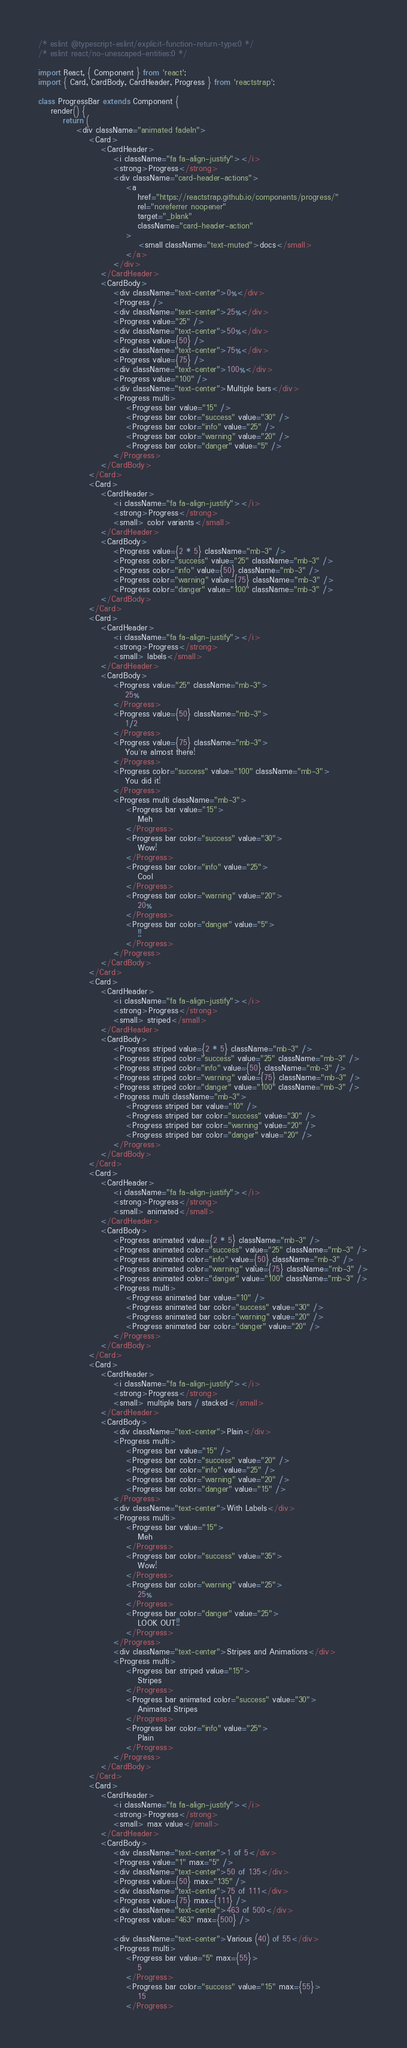Convert code to text. <code><loc_0><loc_0><loc_500><loc_500><_JavaScript_>/* eslint @typescript-eslint/explicit-function-return-type:0 */
/* eslint react/no-unescaped-entities:0 */

import React, { Component } from 'react';
import { Card, CardBody, CardHeader, Progress } from 'reactstrap';

class ProgressBar extends Component {
    render() {
        return (
            <div className="animated fadeIn">
                <Card>
                    <CardHeader>
                        <i className="fa fa-align-justify"></i>
                        <strong>Progress</strong>
                        <div className="card-header-actions">
                            <a
                                href="https://reactstrap.github.io/components/progress/"
                                rel="noreferrer noopener"
                                target="_blank"
                                className="card-header-action"
                            >
                                <small className="text-muted">docs</small>
                            </a>
                        </div>
                    </CardHeader>
                    <CardBody>
                        <div className="text-center">0%</div>
                        <Progress />
                        <div className="text-center">25%</div>
                        <Progress value="25" />
                        <div className="text-center">50%</div>
                        <Progress value={50} />
                        <div className="text-center">75%</div>
                        <Progress value={75} />
                        <div className="text-center">100%</div>
                        <Progress value="100" />
                        <div className="text-center">Multiple bars</div>
                        <Progress multi>
                            <Progress bar value="15" />
                            <Progress bar color="success" value="30" />
                            <Progress bar color="info" value="25" />
                            <Progress bar color="warning" value="20" />
                            <Progress bar color="danger" value="5" />
                        </Progress>
                    </CardBody>
                </Card>
                <Card>
                    <CardHeader>
                        <i className="fa fa-align-justify"></i>
                        <strong>Progress</strong>
                        <small> color variants</small>
                    </CardHeader>
                    <CardBody>
                        <Progress value={2 * 5} className="mb-3" />
                        <Progress color="success" value="25" className="mb-3" />
                        <Progress color="info" value={50} className="mb-3" />
                        <Progress color="warning" value={75} className="mb-3" />
                        <Progress color="danger" value="100" className="mb-3" />
                    </CardBody>
                </Card>
                <Card>
                    <CardHeader>
                        <i className="fa fa-align-justify"></i>
                        <strong>Progress</strong>
                        <small> labels</small>
                    </CardHeader>
                    <CardBody>
                        <Progress value="25" className="mb-3">
                            25%
                        </Progress>
                        <Progress value={50} className="mb-3">
                            1/2
                        </Progress>
                        <Progress value={75} className="mb-3">
                            You're almost there!
                        </Progress>
                        <Progress color="success" value="100" className="mb-3">
                            You did it!
                        </Progress>
                        <Progress multi className="mb-3">
                            <Progress bar value="15">
                                Meh
                            </Progress>
                            <Progress bar color="success" value="30">
                                Wow!
                            </Progress>
                            <Progress bar color="info" value="25">
                                Cool
                            </Progress>
                            <Progress bar color="warning" value="20">
                                20%
                            </Progress>
                            <Progress bar color="danger" value="5">
                                !!
                            </Progress>
                        </Progress>
                    </CardBody>
                </Card>
                <Card>
                    <CardHeader>
                        <i className="fa fa-align-justify"></i>
                        <strong>Progress</strong>
                        <small> striped</small>
                    </CardHeader>
                    <CardBody>
                        <Progress striped value={2 * 5} className="mb-3" />
                        <Progress striped color="success" value="25" className="mb-3" />
                        <Progress striped color="info" value={50} className="mb-3" />
                        <Progress striped color="warning" value={75} className="mb-3" />
                        <Progress striped color="danger" value="100" className="mb-3" />
                        <Progress multi className="mb-3">
                            <Progress striped bar value="10" />
                            <Progress striped bar color="success" value="30" />
                            <Progress striped bar color="warning" value="20" />
                            <Progress striped bar color="danger" value="20" />
                        </Progress>
                    </CardBody>
                </Card>
                <Card>
                    <CardHeader>
                        <i className="fa fa-align-justify"></i>
                        <strong>Progress</strong>
                        <small> animated</small>
                    </CardHeader>
                    <CardBody>
                        <Progress animated value={2 * 5} className="mb-3" />
                        <Progress animated color="success" value="25" className="mb-3" />
                        <Progress animated color="info" value={50} className="mb-3" />
                        <Progress animated color="warning" value={75} className="mb-3" />
                        <Progress animated color="danger" value="100" className="mb-3" />
                        <Progress multi>
                            <Progress animated bar value="10" />
                            <Progress animated bar color="success" value="30" />
                            <Progress animated bar color="warning" value="20" />
                            <Progress animated bar color="danger" value="20" />
                        </Progress>
                    </CardBody>
                </Card>
                <Card>
                    <CardHeader>
                        <i className="fa fa-align-justify"></i>
                        <strong>Progress</strong>
                        <small> multiple bars / stacked</small>
                    </CardHeader>
                    <CardBody>
                        <div className="text-center">Plain</div>
                        <Progress multi>
                            <Progress bar value="15" />
                            <Progress bar color="success" value="20" />
                            <Progress bar color="info" value="25" />
                            <Progress bar color="warning" value="20" />
                            <Progress bar color="danger" value="15" />
                        </Progress>
                        <div className="text-center">With Labels</div>
                        <Progress multi>
                            <Progress bar value="15">
                                Meh
                            </Progress>
                            <Progress bar color="success" value="35">
                                Wow!
                            </Progress>
                            <Progress bar color="warning" value="25">
                                25%
                            </Progress>
                            <Progress bar color="danger" value="25">
                                LOOK OUT!!
                            </Progress>
                        </Progress>
                        <div className="text-center">Stripes and Animations</div>
                        <Progress multi>
                            <Progress bar striped value="15">
                                Stripes
                            </Progress>
                            <Progress bar animated color="success" value="30">
                                Animated Stripes
                            </Progress>
                            <Progress bar color="info" value="25">
                                Plain
                            </Progress>
                        </Progress>
                    </CardBody>
                </Card>
                <Card>
                    <CardHeader>
                        <i className="fa fa-align-justify"></i>
                        <strong>Progress</strong>
                        <small> max value</small>
                    </CardHeader>
                    <CardBody>
                        <div className="text-center">1 of 5</div>
                        <Progress value="1" max="5" />
                        <div className="text-center">50 of 135</div>
                        <Progress value={50} max="135" />
                        <div className="text-center">75 of 111</div>
                        <Progress value={75} max={111} />
                        <div className="text-center">463 of 500</div>
                        <Progress value="463" max={500} />

                        <div className="text-center">Various (40) of 55</div>
                        <Progress multi>
                            <Progress bar value="5" max={55}>
                                5
                            </Progress>
                            <Progress bar color="success" value="15" max={55}>
                                15
                            </Progress></code> 